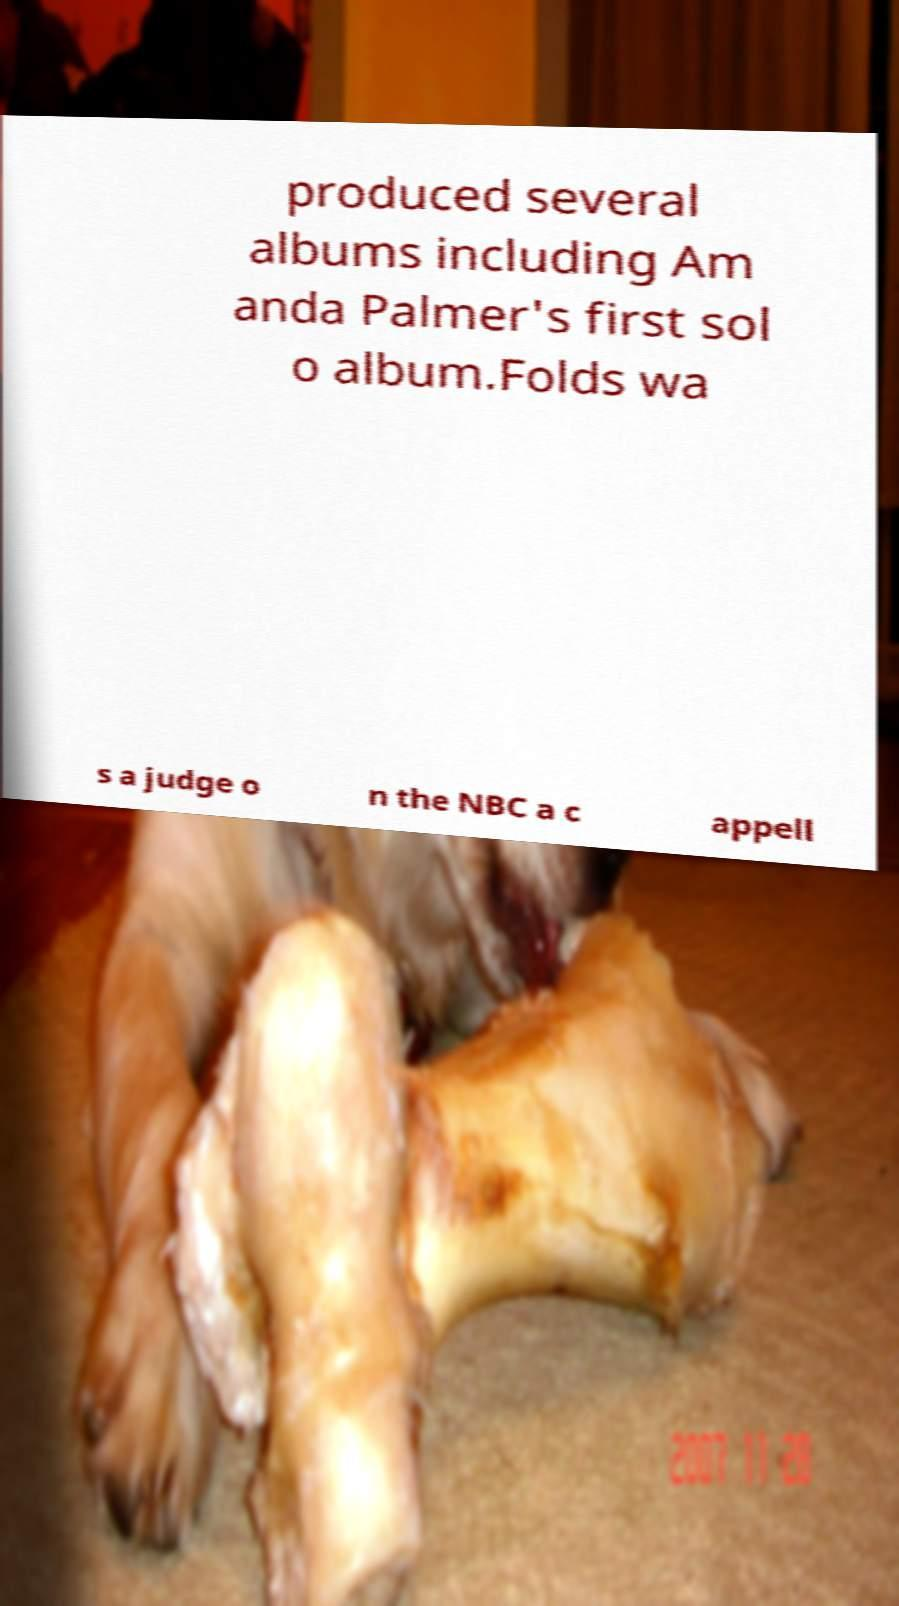Can you accurately transcribe the text from the provided image for me? produced several albums including Am anda Palmer's first sol o album.Folds wa s a judge o n the NBC a c appell 